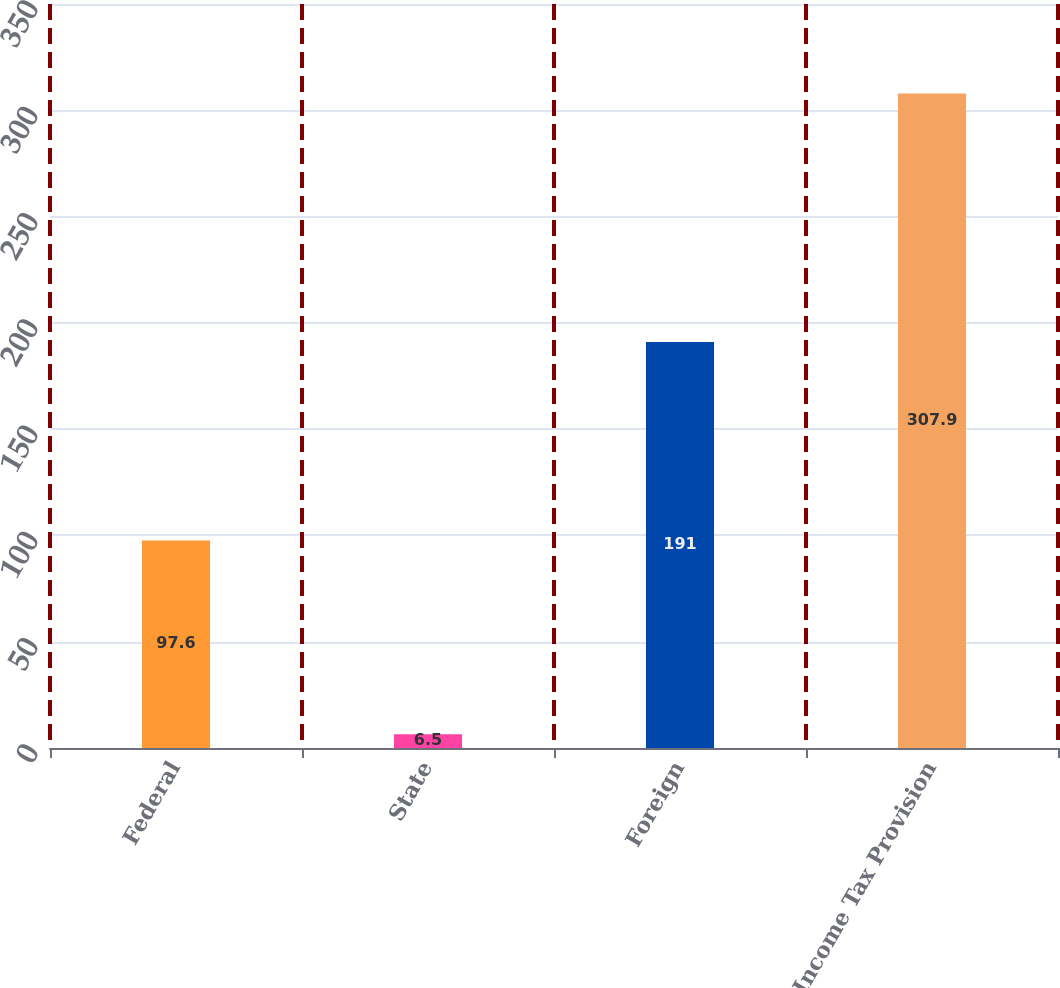<chart> <loc_0><loc_0><loc_500><loc_500><bar_chart><fcel>Federal<fcel>State<fcel>Foreign<fcel>Income Tax Provision<nl><fcel>97.6<fcel>6.5<fcel>191<fcel>307.9<nl></chart> 